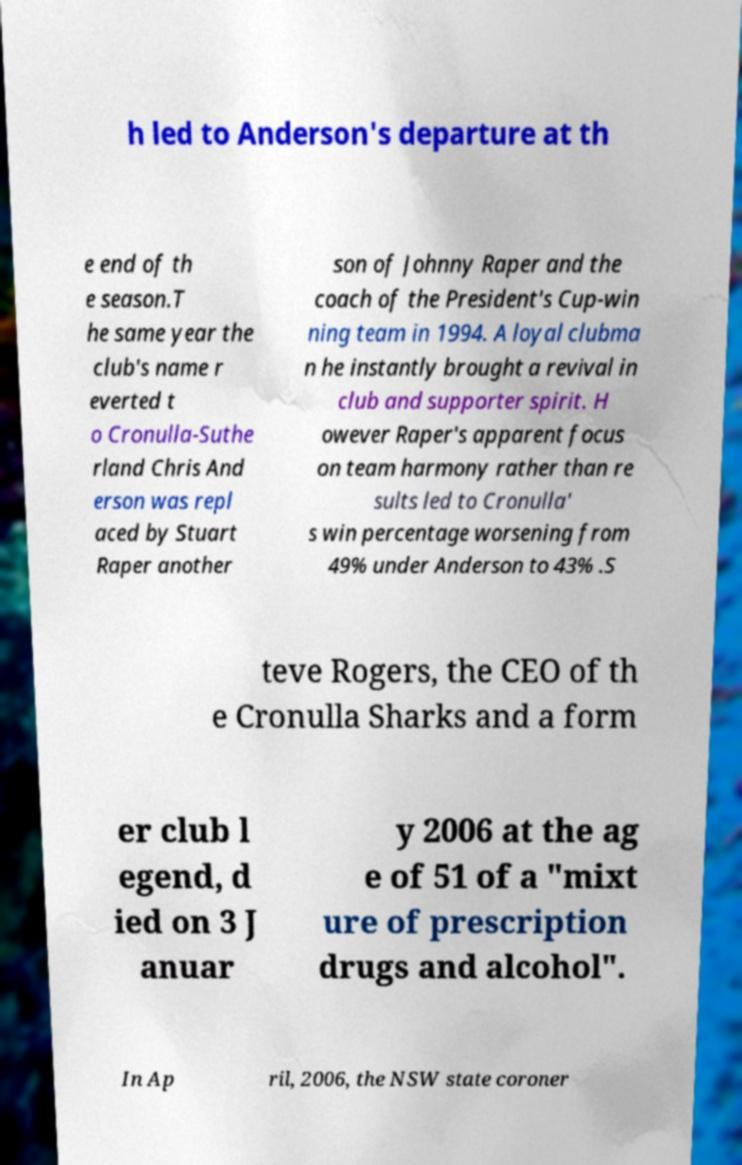Can you read and provide the text displayed in the image?This photo seems to have some interesting text. Can you extract and type it out for me? h led to Anderson's departure at th e end of th e season.T he same year the club's name r everted t o Cronulla-Suthe rland Chris And erson was repl aced by Stuart Raper another son of Johnny Raper and the coach of the President's Cup-win ning team in 1994. A loyal clubma n he instantly brought a revival in club and supporter spirit. H owever Raper's apparent focus on team harmony rather than re sults led to Cronulla' s win percentage worsening from 49% under Anderson to 43% .S teve Rogers, the CEO of th e Cronulla Sharks and a form er club l egend, d ied on 3 J anuar y 2006 at the ag e of 51 of a "mixt ure of prescription drugs and alcohol". In Ap ril, 2006, the NSW state coroner 